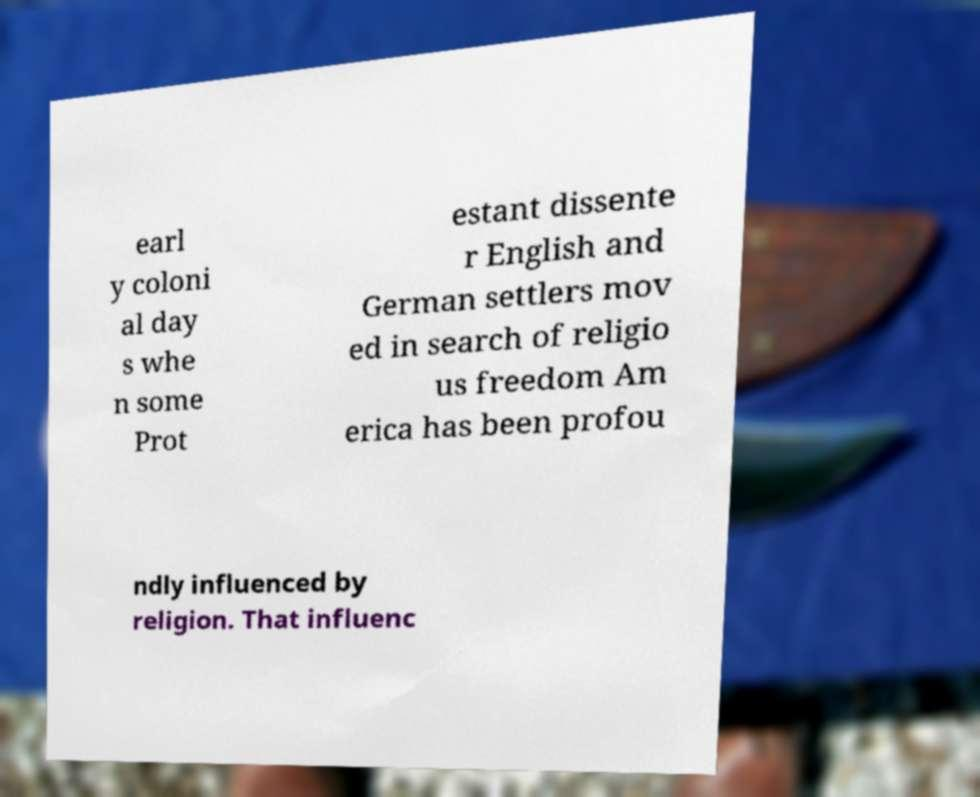For documentation purposes, I need the text within this image transcribed. Could you provide that? earl y coloni al day s whe n some Prot estant dissente r English and German settlers mov ed in search of religio us freedom Am erica has been profou ndly influenced by religion. That influenc 